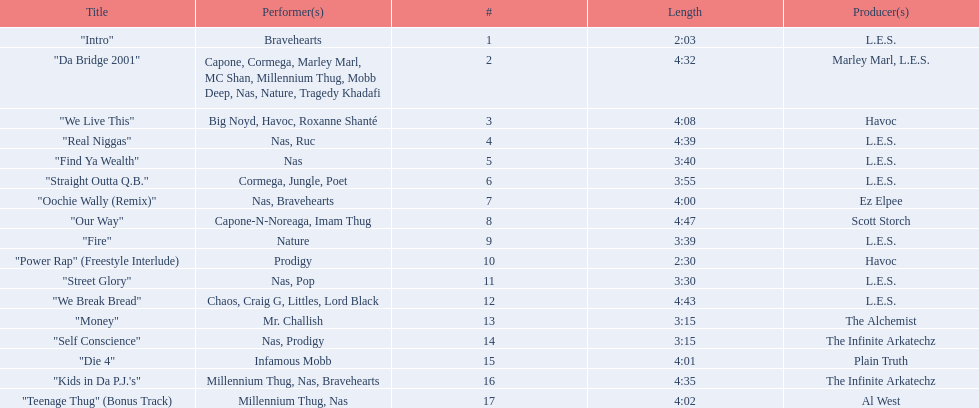Write the full table. {'header': ['Title', 'Performer(s)', '#', 'Length', 'Producer(s)'], 'rows': [['"Intro"', 'Bravehearts', '1', '2:03', 'L.E.S.'], ['"Da Bridge 2001"', 'Capone, Cormega, Marley Marl, MC Shan, Millennium Thug, Mobb Deep, Nas, Nature, Tragedy Khadafi', '2', '4:32', 'Marley Marl, L.E.S.'], ['"We Live This"', 'Big Noyd, Havoc, Roxanne Shanté', '3', '4:08', 'Havoc'], ['"Real Niggas"', 'Nas, Ruc', '4', '4:39', 'L.E.S.'], ['"Find Ya Wealth"', 'Nas', '5', '3:40', 'L.E.S.'], ['"Straight Outta Q.B."', 'Cormega, Jungle, Poet', '6', '3:55', 'L.E.S.'], ['"Oochie Wally (Remix)"', 'Nas, Bravehearts', '7', '4:00', 'Ez Elpee'], ['"Our Way"', 'Capone-N-Noreaga, Imam Thug', '8', '4:47', 'Scott Storch'], ['"Fire"', 'Nature', '9', '3:39', 'L.E.S.'], ['"Power Rap" (Freestyle Interlude)', 'Prodigy', '10', '2:30', 'Havoc'], ['"Street Glory"', 'Nas, Pop', '11', '3:30', 'L.E.S.'], ['"We Break Bread"', 'Chaos, Craig G, Littles, Lord Black', '12', '4:43', 'L.E.S.'], ['"Money"', 'Mr. Challish', '13', '3:15', 'The Alchemist'], ['"Self Conscience"', 'Nas, Prodigy', '14', '3:15', 'The Infinite Arkatechz'], ['"Die 4"', 'Infamous Mobb', '15', '4:01', 'Plain Truth'], ['"Kids in Da P.J.\'s"', 'Millennium Thug, Nas, Bravehearts', '16', '4:35', 'The Infinite Arkatechz'], ['"Teenage Thug" (Bonus Track)', 'Millennium Thug, Nas', '17', '4:02', 'Al West']]} What are all the songs on the album? "Intro", "Da Bridge 2001", "We Live This", "Real Niggas", "Find Ya Wealth", "Straight Outta Q.B.", "Oochie Wally (Remix)", "Our Way", "Fire", "Power Rap" (Freestyle Interlude), "Street Glory", "We Break Bread", "Money", "Self Conscience", "Die 4", "Kids in Da P.J.'s", "Teenage Thug" (Bonus Track). Which is the shortest? "Intro". How long is that song? 2:03. 